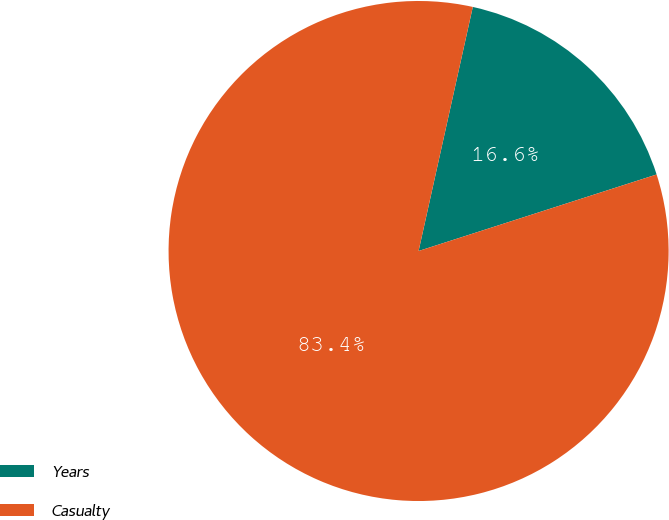<chart> <loc_0><loc_0><loc_500><loc_500><pie_chart><fcel>Years<fcel>Casualty<nl><fcel>16.57%<fcel>83.43%<nl></chart> 